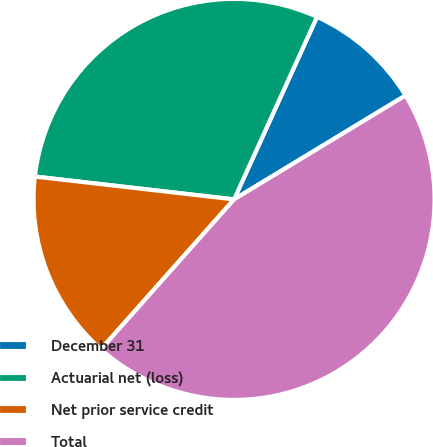<chart> <loc_0><loc_0><loc_500><loc_500><pie_chart><fcel>December 31<fcel>Actuarial net (loss)<fcel>Net prior service credit<fcel>Total<nl><fcel>9.54%<fcel>29.97%<fcel>15.26%<fcel>45.23%<nl></chart> 